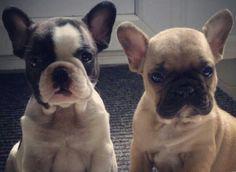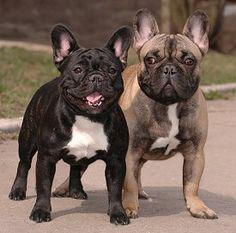The first image is the image on the left, the second image is the image on the right. Examine the images to the left and right. Is the description "In one of the images there are three dogs." accurate? Answer yes or no. No. The first image is the image on the left, the second image is the image on the right. Analyze the images presented: Is the assertion "There are exactly three dogs in total." valid? Answer yes or no. No. 